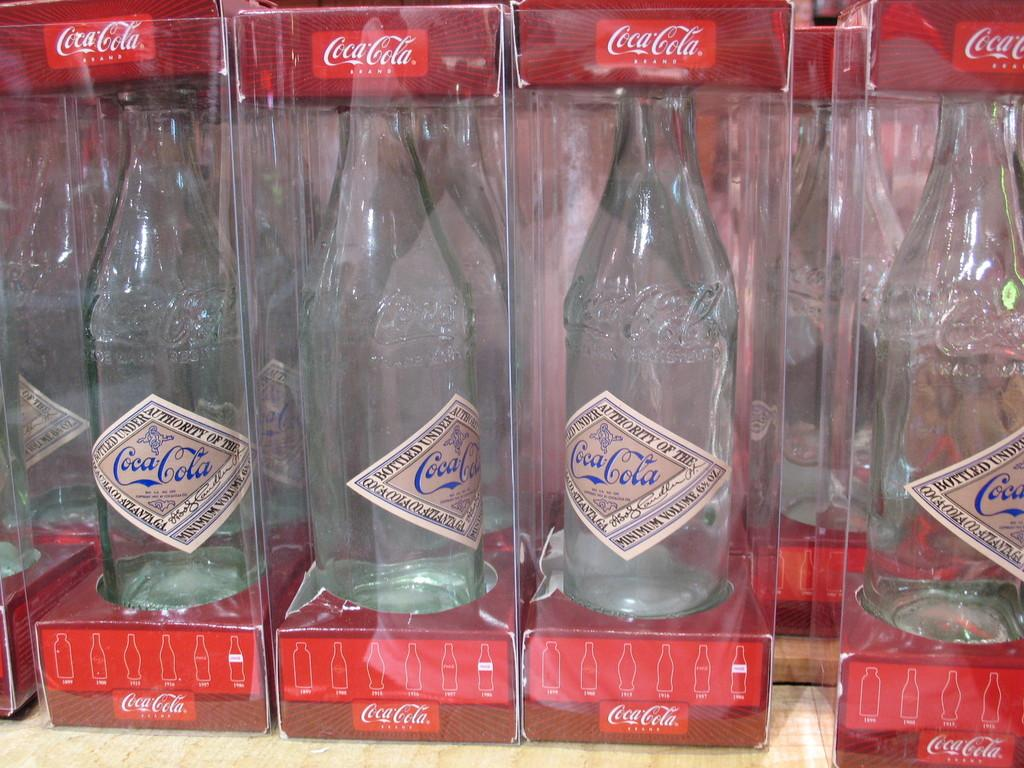What objects can be seen in the image? There are boxes in the image. What are the boxes containing? The boxes contain glass bottles. What type of noise can be heard coming from the boxes in the image? There is no indication of any noise in the image, as it only shows boxes containing glass bottles. 